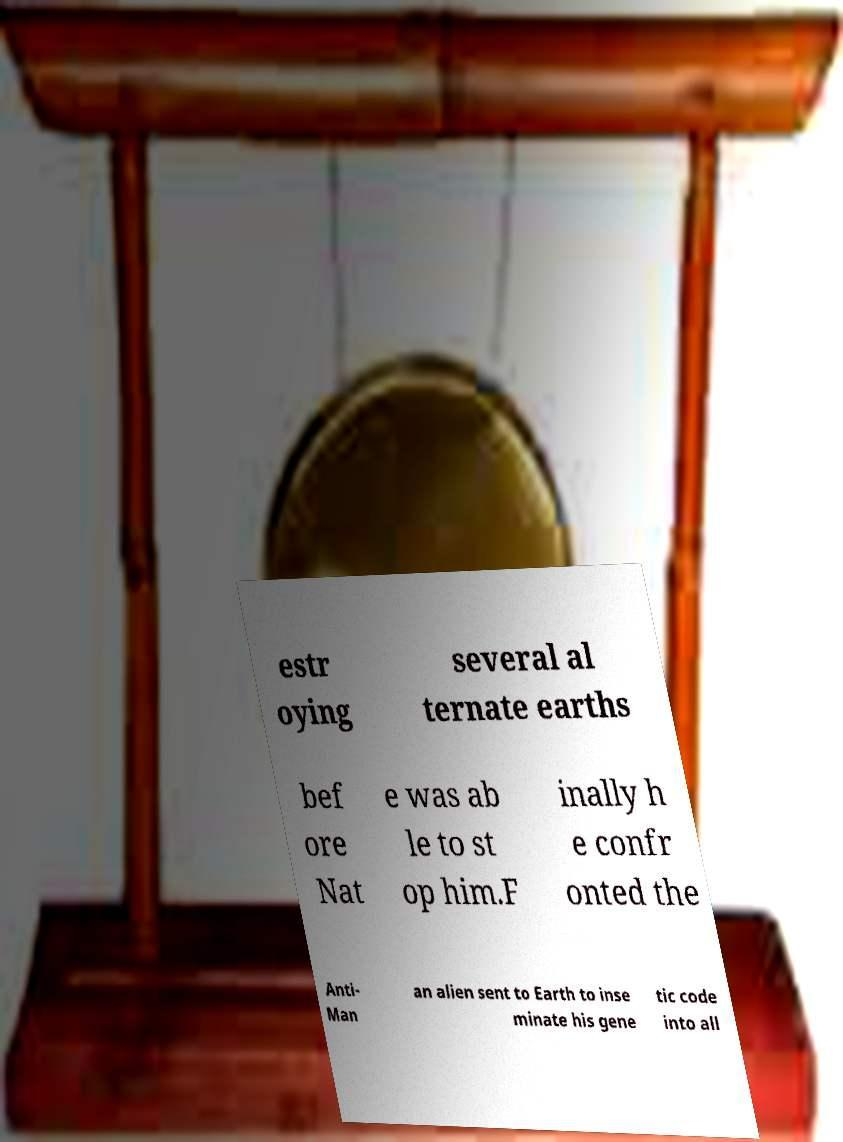Could you assist in decoding the text presented in this image and type it out clearly? estr oying several al ternate earths bef ore Nat e was ab le to st op him.F inally h e confr onted the Anti- Man an alien sent to Earth to inse minate his gene tic code into all 